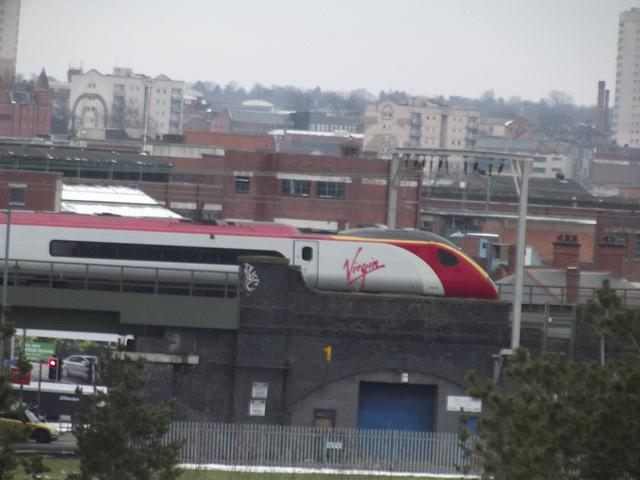The owners of this company first started it in which business?

Choices:
A) spaceship
B) record
C) phones
D) airline record 